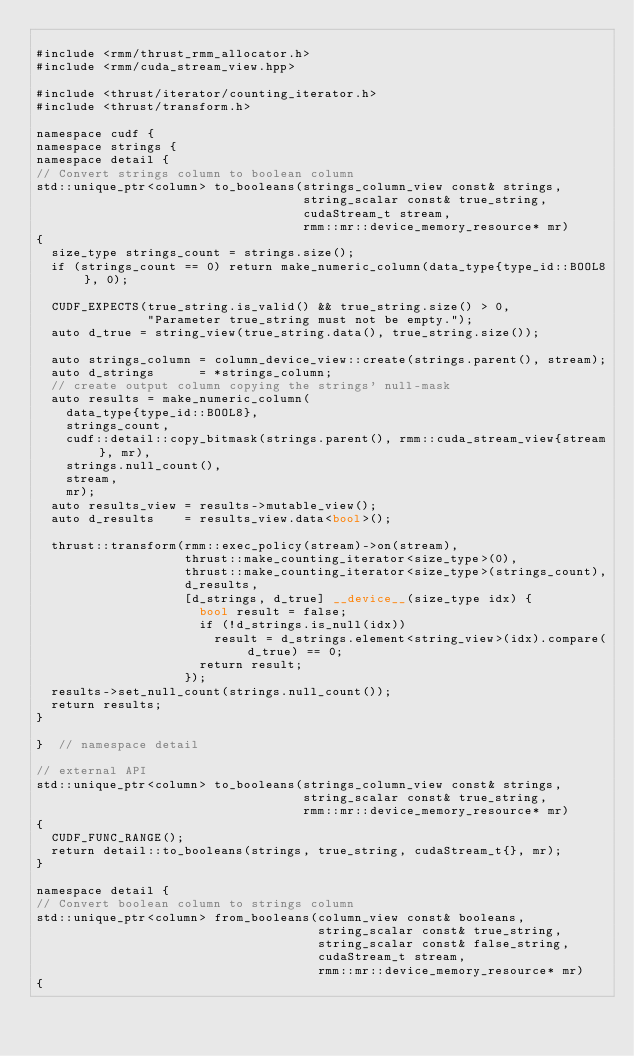<code> <loc_0><loc_0><loc_500><loc_500><_Cuda_>
#include <rmm/thrust_rmm_allocator.h>
#include <rmm/cuda_stream_view.hpp>

#include <thrust/iterator/counting_iterator.h>
#include <thrust/transform.h>

namespace cudf {
namespace strings {
namespace detail {
// Convert strings column to boolean column
std::unique_ptr<column> to_booleans(strings_column_view const& strings,
                                    string_scalar const& true_string,
                                    cudaStream_t stream,
                                    rmm::mr::device_memory_resource* mr)
{
  size_type strings_count = strings.size();
  if (strings_count == 0) return make_numeric_column(data_type{type_id::BOOL8}, 0);

  CUDF_EXPECTS(true_string.is_valid() && true_string.size() > 0,
               "Parameter true_string must not be empty.");
  auto d_true = string_view(true_string.data(), true_string.size());

  auto strings_column = column_device_view::create(strings.parent(), stream);
  auto d_strings      = *strings_column;
  // create output column copying the strings' null-mask
  auto results = make_numeric_column(
    data_type{type_id::BOOL8},
    strings_count,
    cudf::detail::copy_bitmask(strings.parent(), rmm::cuda_stream_view{stream}, mr),
    strings.null_count(),
    stream,
    mr);
  auto results_view = results->mutable_view();
  auto d_results    = results_view.data<bool>();

  thrust::transform(rmm::exec_policy(stream)->on(stream),
                    thrust::make_counting_iterator<size_type>(0),
                    thrust::make_counting_iterator<size_type>(strings_count),
                    d_results,
                    [d_strings, d_true] __device__(size_type idx) {
                      bool result = false;
                      if (!d_strings.is_null(idx))
                        result = d_strings.element<string_view>(idx).compare(d_true) == 0;
                      return result;
                    });
  results->set_null_count(strings.null_count());
  return results;
}

}  // namespace detail

// external API
std::unique_ptr<column> to_booleans(strings_column_view const& strings,
                                    string_scalar const& true_string,
                                    rmm::mr::device_memory_resource* mr)
{
  CUDF_FUNC_RANGE();
  return detail::to_booleans(strings, true_string, cudaStream_t{}, mr);
}

namespace detail {
// Convert boolean column to strings column
std::unique_ptr<column> from_booleans(column_view const& booleans,
                                      string_scalar const& true_string,
                                      string_scalar const& false_string,
                                      cudaStream_t stream,
                                      rmm::mr::device_memory_resource* mr)
{</code> 